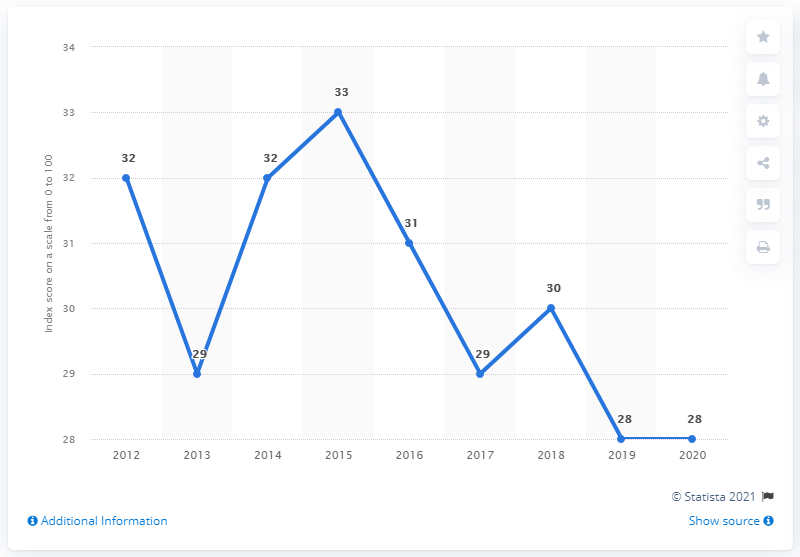Identify some key points in this picture. In 2012, the Dominican Republic's corruption perception index was at its lowest point. In 2019 and 2020, the Dominican Republic's corruption perception index score was 28, indicating a perceived level of corruption in the country of "high" according to the Transparency International's Corruption Perception Index. In the year 2018, the Corruption Perception Index score for the Dominican Republic was 30. The Corruption Perception Index score of the Dominican Republic was 28 two times in the year. 